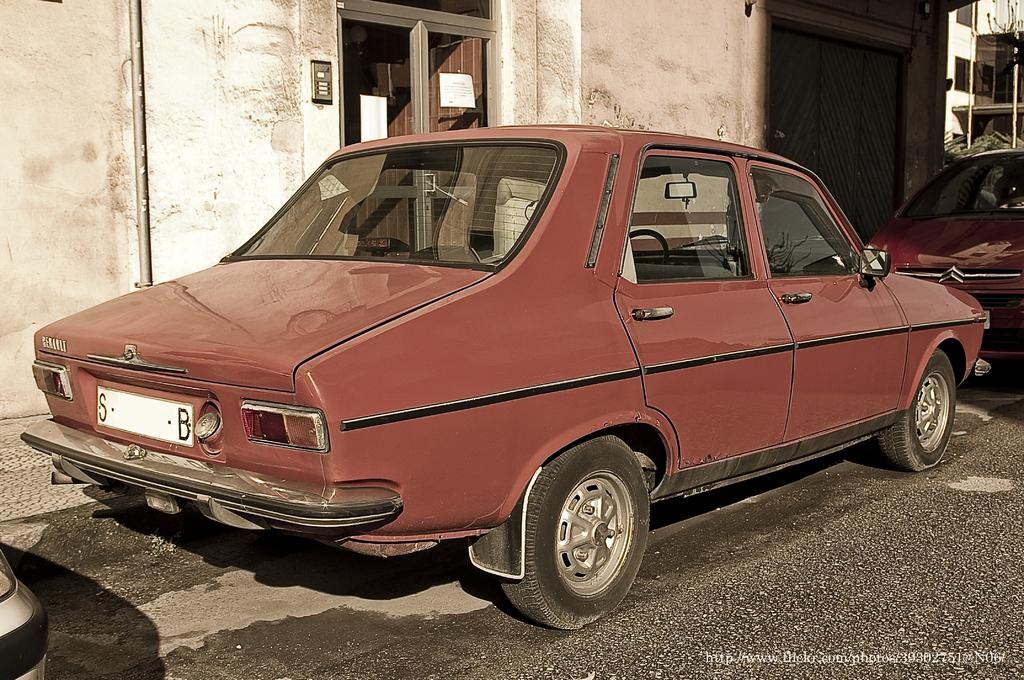How many cars can be seen on the road in the image? There are 2 cars on the road in the image. What can be seen in the background of the image? There are buildings in the background of the image. Is there any additional information or marking on the image? Yes, there is a watermark on the right bottom of the image. What type of skirt is the car wearing in the image? Cars do not wear skirts; they are vehicles. The question is not relevant to the image. 